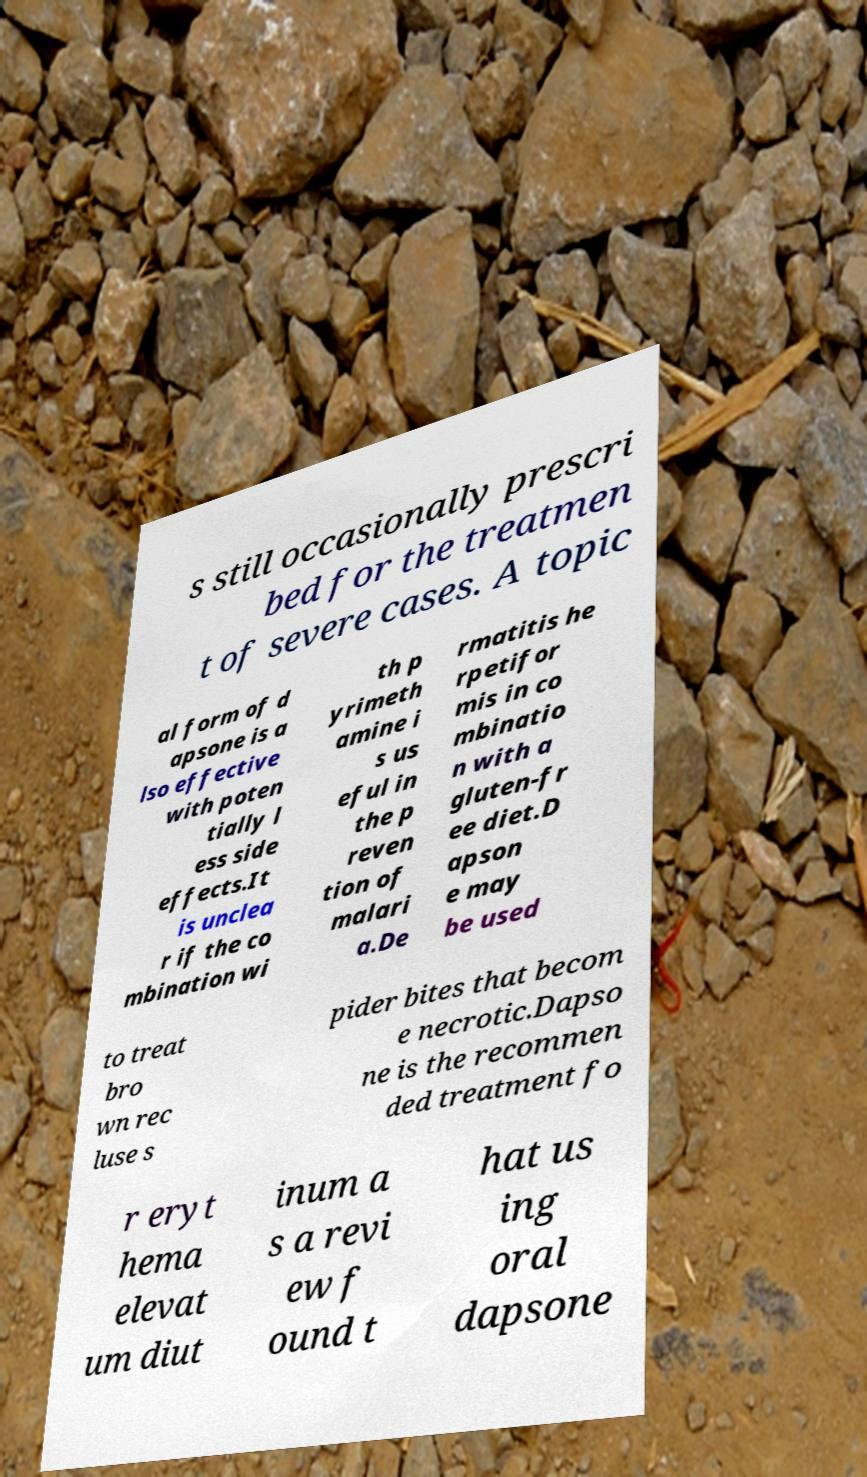Please read and relay the text visible in this image. What does it say? s still occasionally prescri bed for the treatmen t of severe cases. A topic al form of d apsone is a lso effective with poten tially l ess side effects.It is unclea r if the co mbination wi th p yrimeth amine i s us eful in the p reven tion of malari a.De rmatitis he rpetifor mis in co mbinatio n with a gluten-fr ee diet.D apson e may be used to treat bro wn rec luse s pider bites that becom e necrotic.Dapso ne is the recommen ded treatment fo r eryt hema elevat um diut inum a s a revi ew f ound t hat us ing oral dapsone 